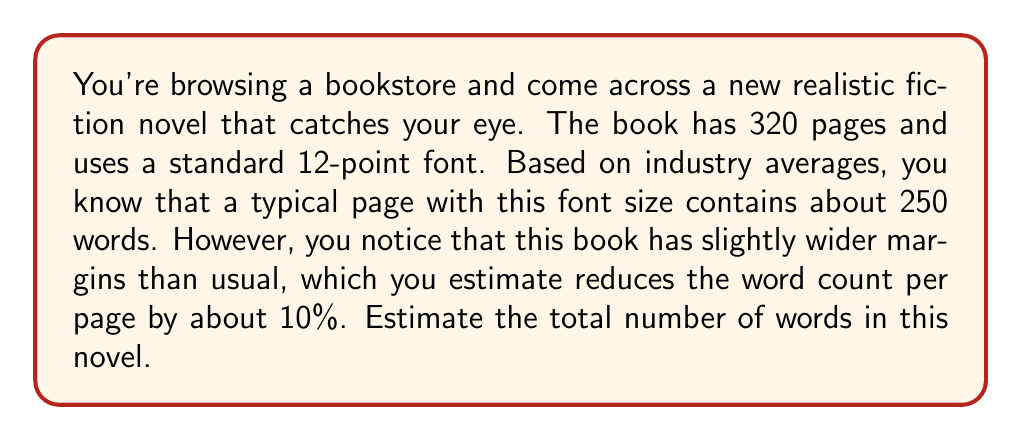Show me your answer to this math problem. To estimate the number of words in the novel, we'll follow these steps:

1. Calculate the typical word count per page:
   A standard page with 12-point font contains about 250 words.

2. Adjust for the wider margins:
   The wider margins reduce the word count by 10%.
   Adjusted words per page = $250 \times (1 - 0.10) = 250 \times 0.90 = 225$ words

3. Calculate the total word count:
   Multiply the adjusted words per page by the total number of pages.

   Let $W$ be the total word count, $P$ be the number of pages, and $w$ be the adjusted words per page.

   $$W = P \times w$$
   $$W = 320 \times 225 = 72,000$$

Therefore, we estimate that the novel contains approximately 72,000 words.
Answer: 72,000 words 